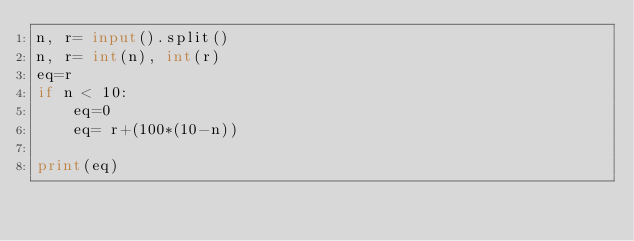<code> <loc_0><loc_0><loc_500><loc_500><_Python_>n, r= input().split()
n, r= int(n), int(r)
eq=r
if n < 10:
	eq=0
	eq= r+(100*(10-n))

print(eq)
</code> 